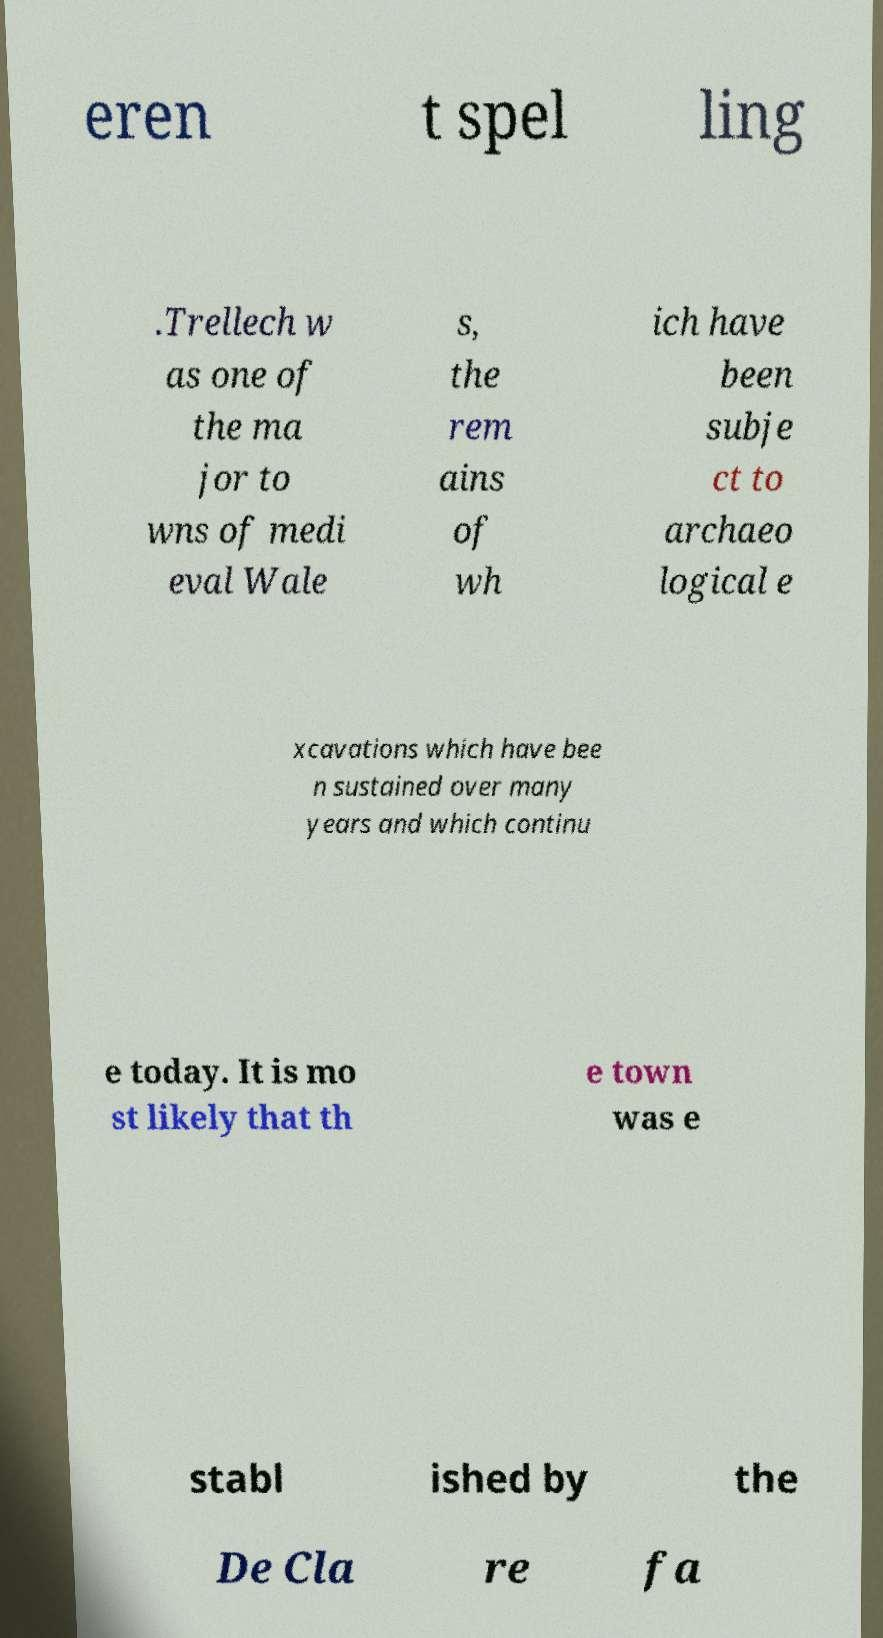There's text embedded in this image that I need extracted. Can you transcribe it verbatim? eren t spel ling .Trellech w as one of the ma jor to wns of medi eval Wale s, the rem ains of wh ich have been subje ct to archaeo logical e xcavations which have bee n sustained over many years and which continu e today. It is mo st likely that th e town was e stabl ished by the De Cla re fa 